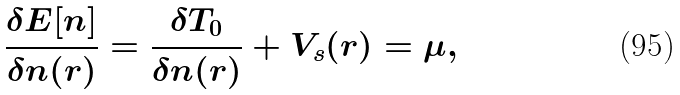Convert formula to latex. <formula><loc_0><loc_0><loc_500><loc_500>\frac { \delta E [ n ] } { \delta n ( { r } ) } = \frac { \delta T _ { 0 } } { \delta n ( { r } ) } + V _ { s } ( { r } ) = \mu ,</formula> 